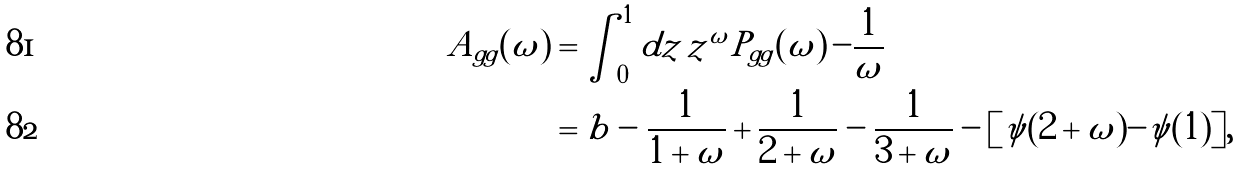Convert formula to latex. <formula><loc_0><loc_0><loc_500><loc_500>A _ { g g } ( \omega ) & = \int _ { 0 } ^ { 1 } d z \, z ^ { \omega } P _ { g g } ( \omega ) \, - \frac { 1 } { \omega } \\ & = b - \frac { 1 } { 1 + \omega } + \frac { 1 } { 2 + \omega } - \frac { 1 } { 3 + \omega } - [ \psi ( 2 + \omega ) - \psi ( 1 ) ] ,</formula> 